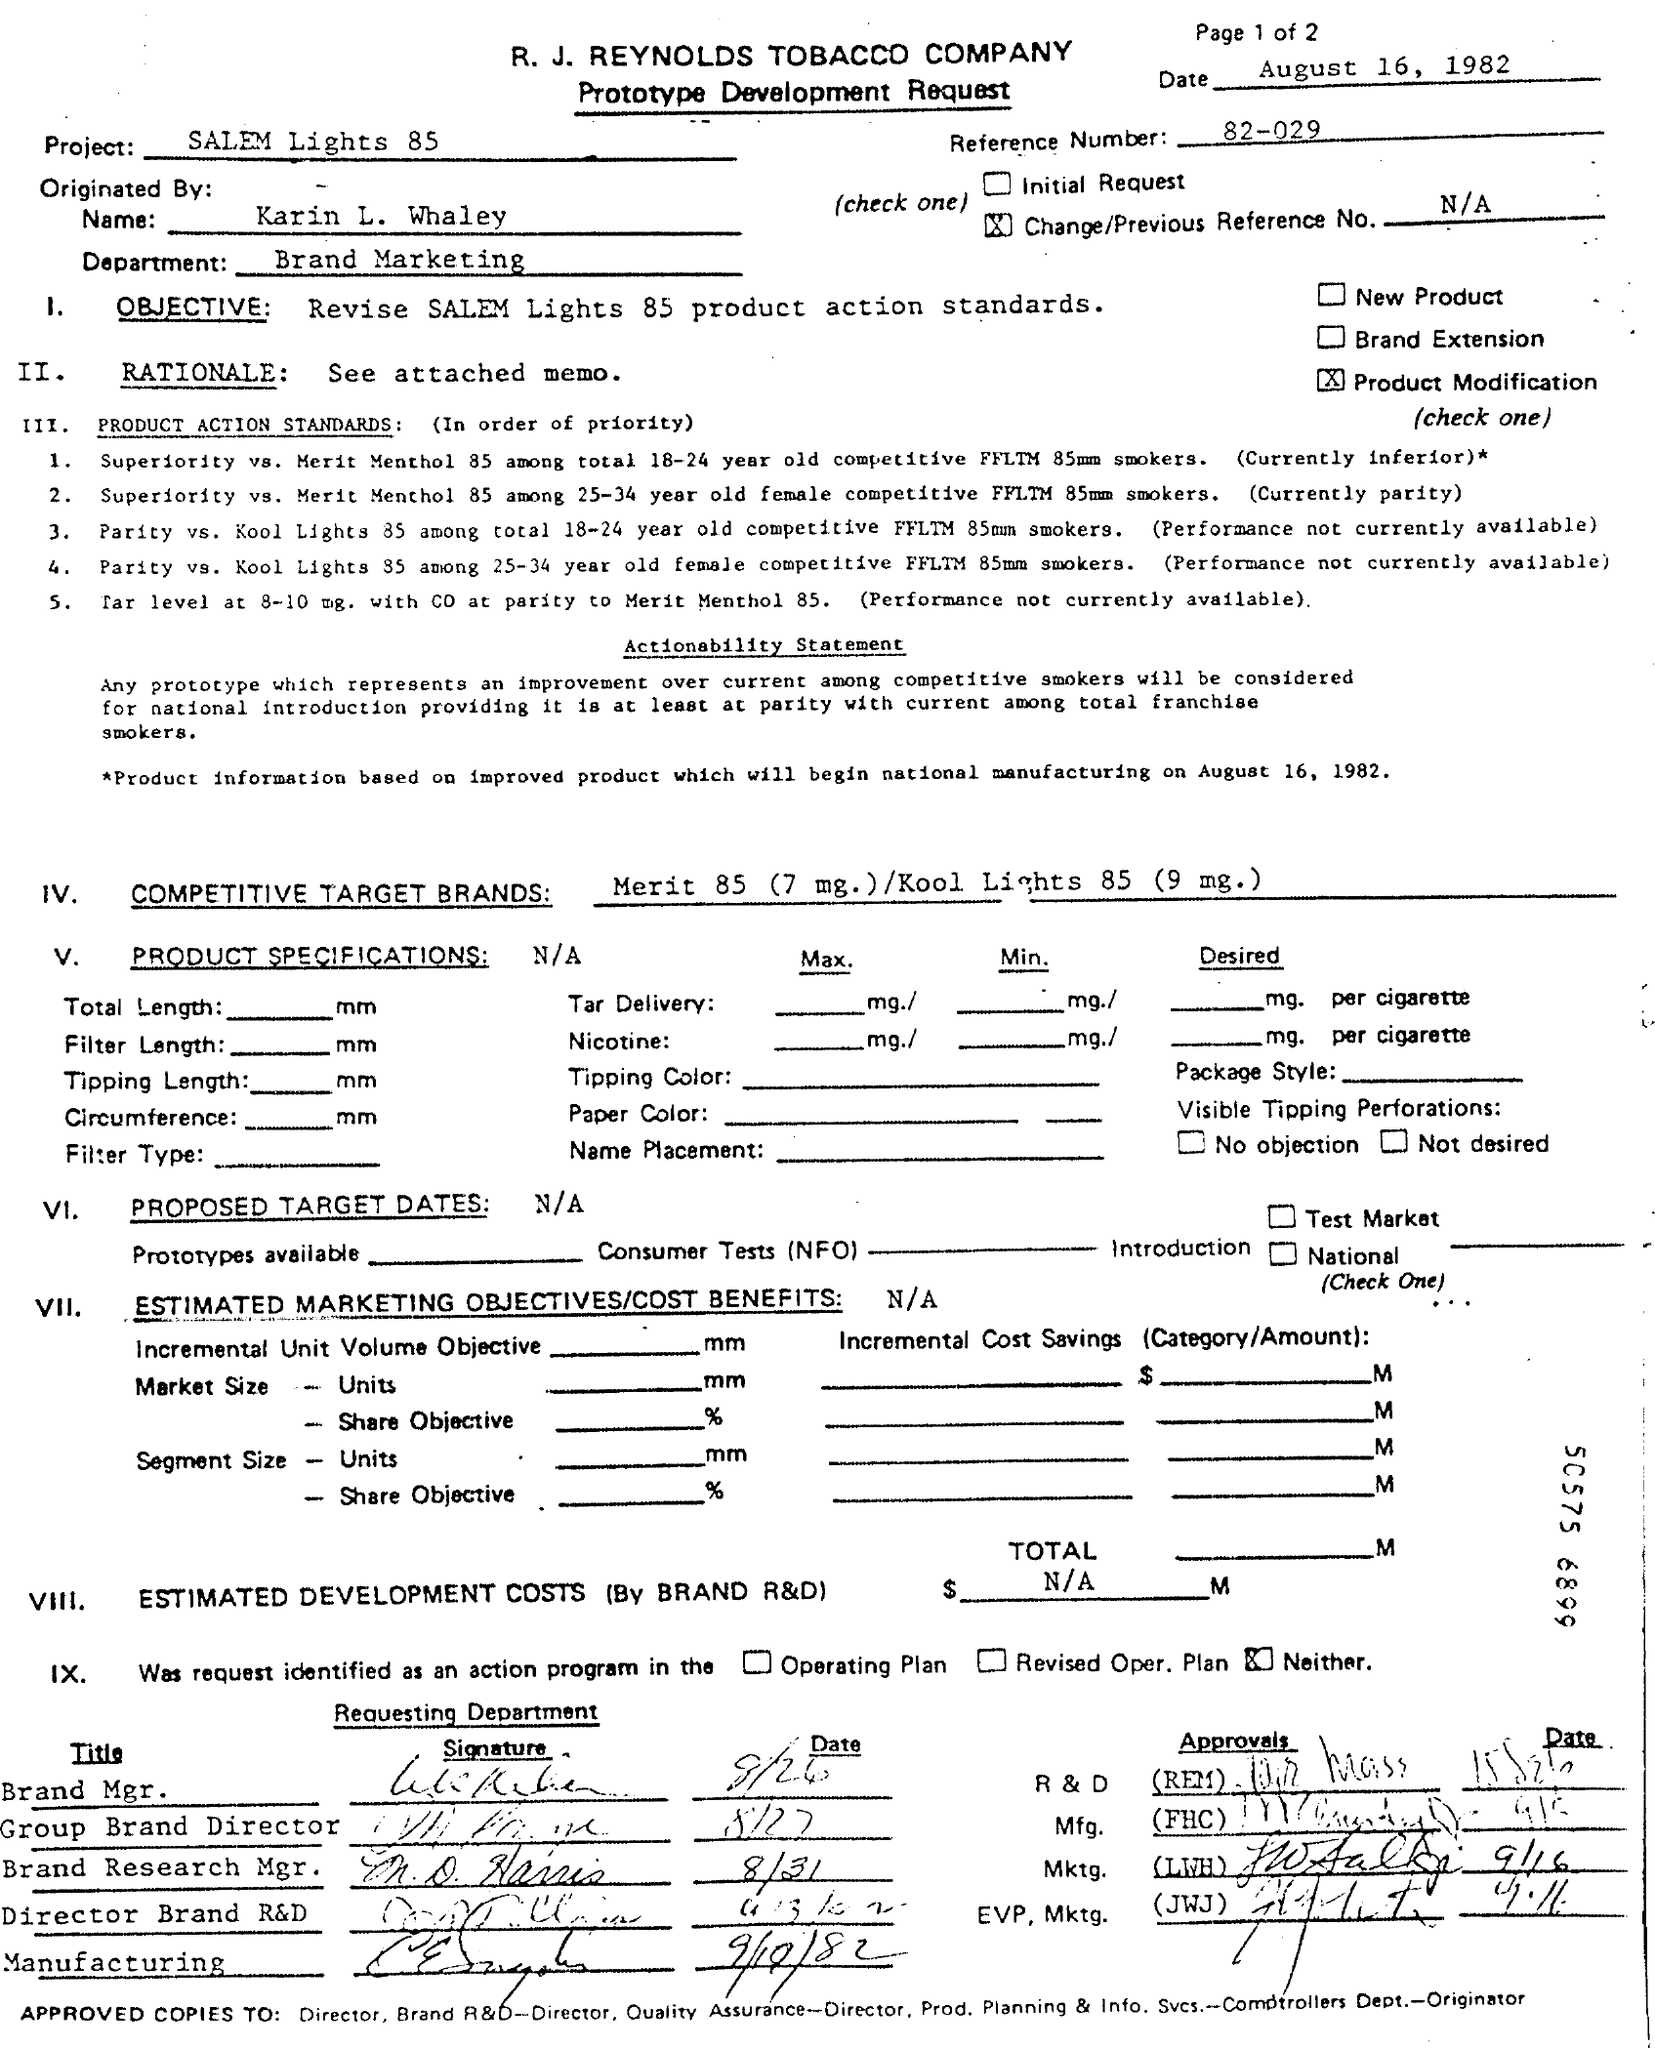What is the type of the request ?
Your answer should be very brief. Prototype development request. When is the document dated ?
Provide a succinct answer. August 16 , 1982. What is the name of the project mentioned in the document ?
Your response must be concise. Salem Lights 85. What is the name of the department mentioned in the given document ?
Offer a terse response. Brand marketing. What is the reference number mentioned in the document ?
Your answer should be very brief. 82-029. By whom this document is originated ?
Give a very brief answer. Karin L. Whaley. What is the objective mentioned in the given document ?
Ensure brevity in your answer.  Revise salem lights 85 product action standards. 